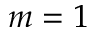Convert formula to latex. <formula><loc_0><loc_0><loc_500><loc_500>m = 1</formula> 